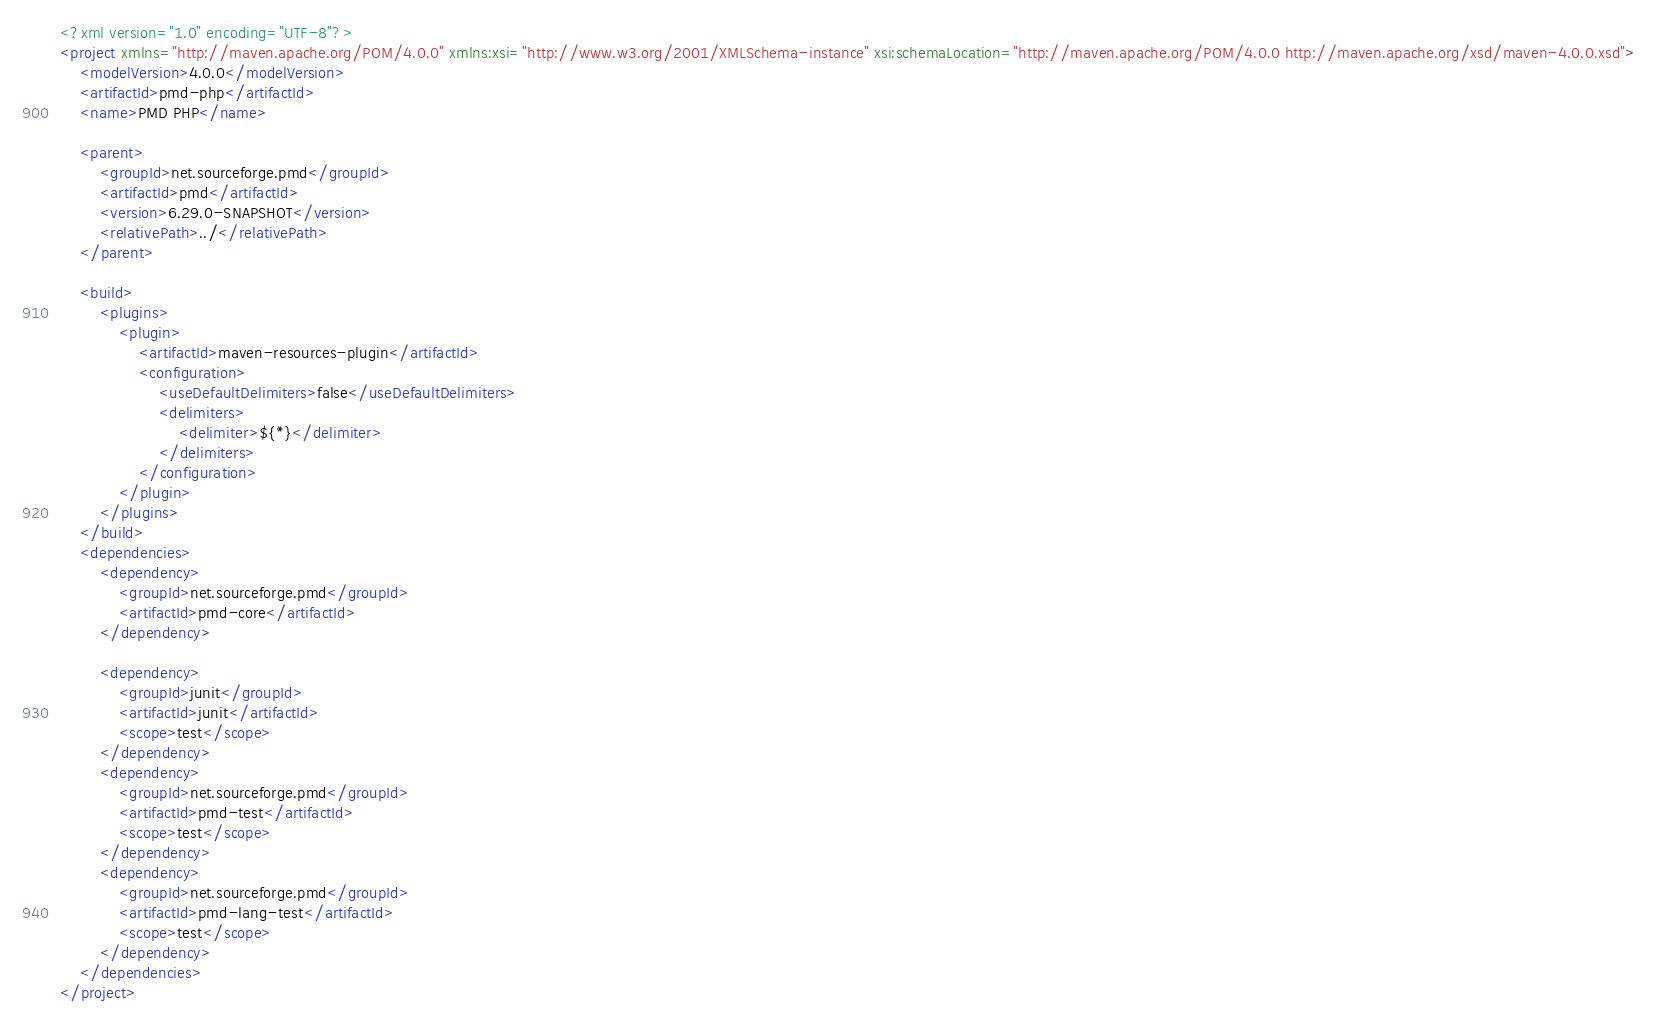Convert code to text. <code><loc_0><loc_0><loc_500><loc_500><_XML_><?xml version="1.0" encoding="UTF-8"?>
<project xmlns="http://maven.apache.org/POM/4.0.0" xmlns:xsi="http://www.w3.org/2001/XMLSchema-instance" xsi:schemaLocation="http://maven.apache.org/POM/4.0.0 http://maven.apache.org/xsd/maven-4.0.0.xsd">
    <modelVersion>4.0.0</modelVersion>
    <artifactId>pmd-php</artifactId>
    <name>PMD PHP</name>

    <parent>
        <groupId>net.sourceforge.pmd</groupId>
        <artifactId>pmd</artifactId>
        <version>6.29.0-SNAPSHOT</version>
        <relativePath>../</relativePath>
    </parent>

    <build>
        <plugins>
            <plugin>
                <artifactId>maven-resources-plugin</artifactId>
                <configuration>
                    <useDefaultDelimiters>false</useDefaultDelimiters>
                    <delimiters>
                        <delimiter>${*}</delimiter>
                    </delimiters>
                </configuration>
            </plugin>
        </plugins>
    </build>
    <dependencies>
        <dependency>
            <groupId>net.sourceforge.pmd</groupId>
            <artifactId>pmd-core</artifactId>
        </dependency>

        <dependency>
            <groupId>junit</groupId>
            <artifactId>junit</artifactId>
            <scope>test</scope>
        </dependency>
        <dependency>
            <groupId>net.sourceforge.pmd</groupId>
            <artifactId>pmd-test</artifactId>
            <scope>test</scope>
        </dependency>
        <dependency>
            <groupId>net.sourceforge.pmd</groupId>
            <artifactId>pmd-lang-test</artifactId>
            <scope>test</scope>
        </dependency>
    </dependencies>
</project>
</code> 